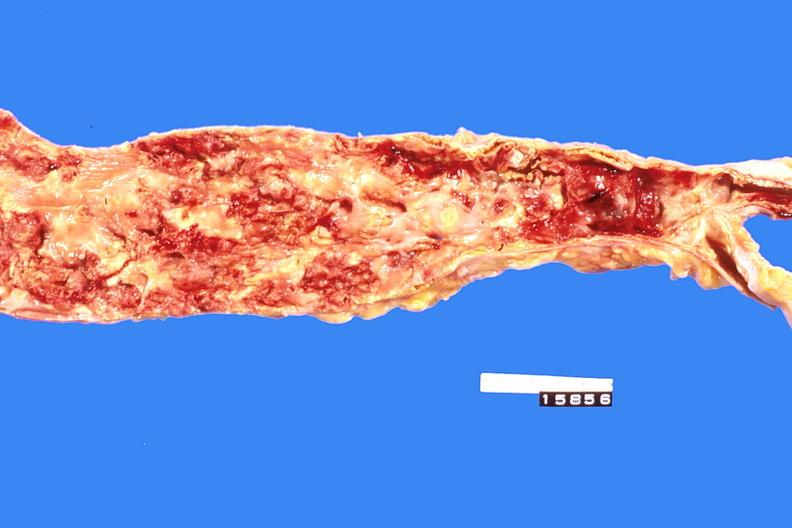s cardiovascular present?
Answer the question using a single word or phrase. Yes 